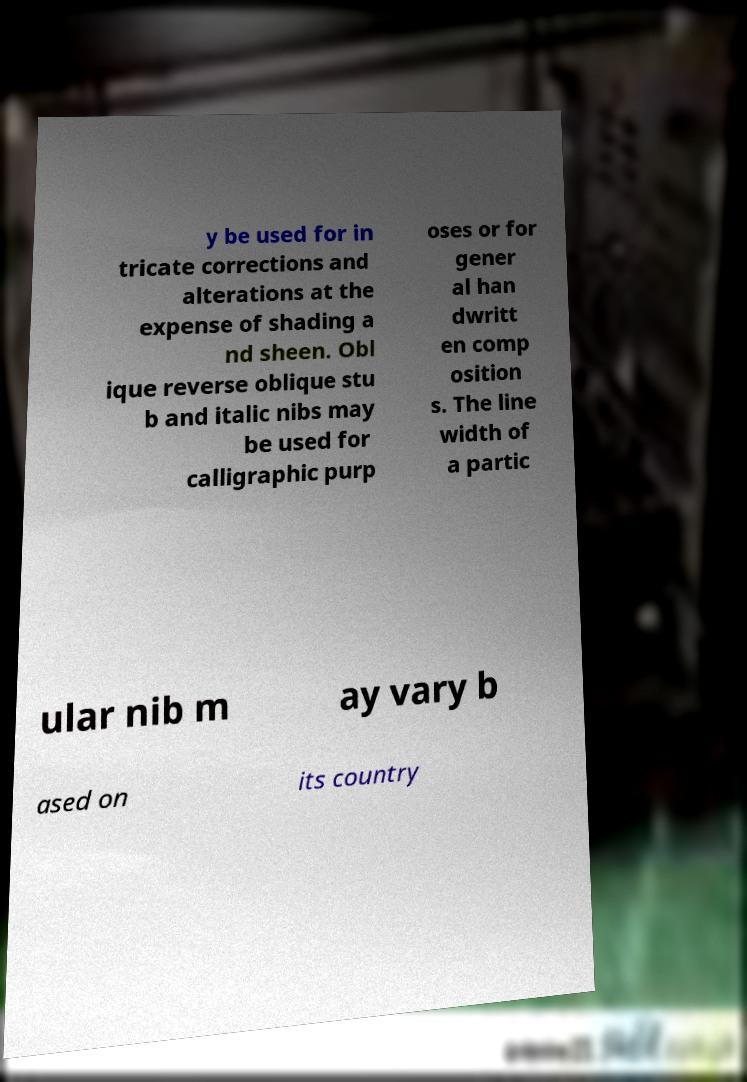Can you accurately transcribe the text from the provided image for me? y be used for in tricate corrections and alterations at the expense of shading a nd sheen. Obl ique reverse oblique stu b and italic nibs may be used for calligraphic purp oses or for gener al han dwritt en comp osition s. The line width of a partic ular nib m ay vary b ased on its country 